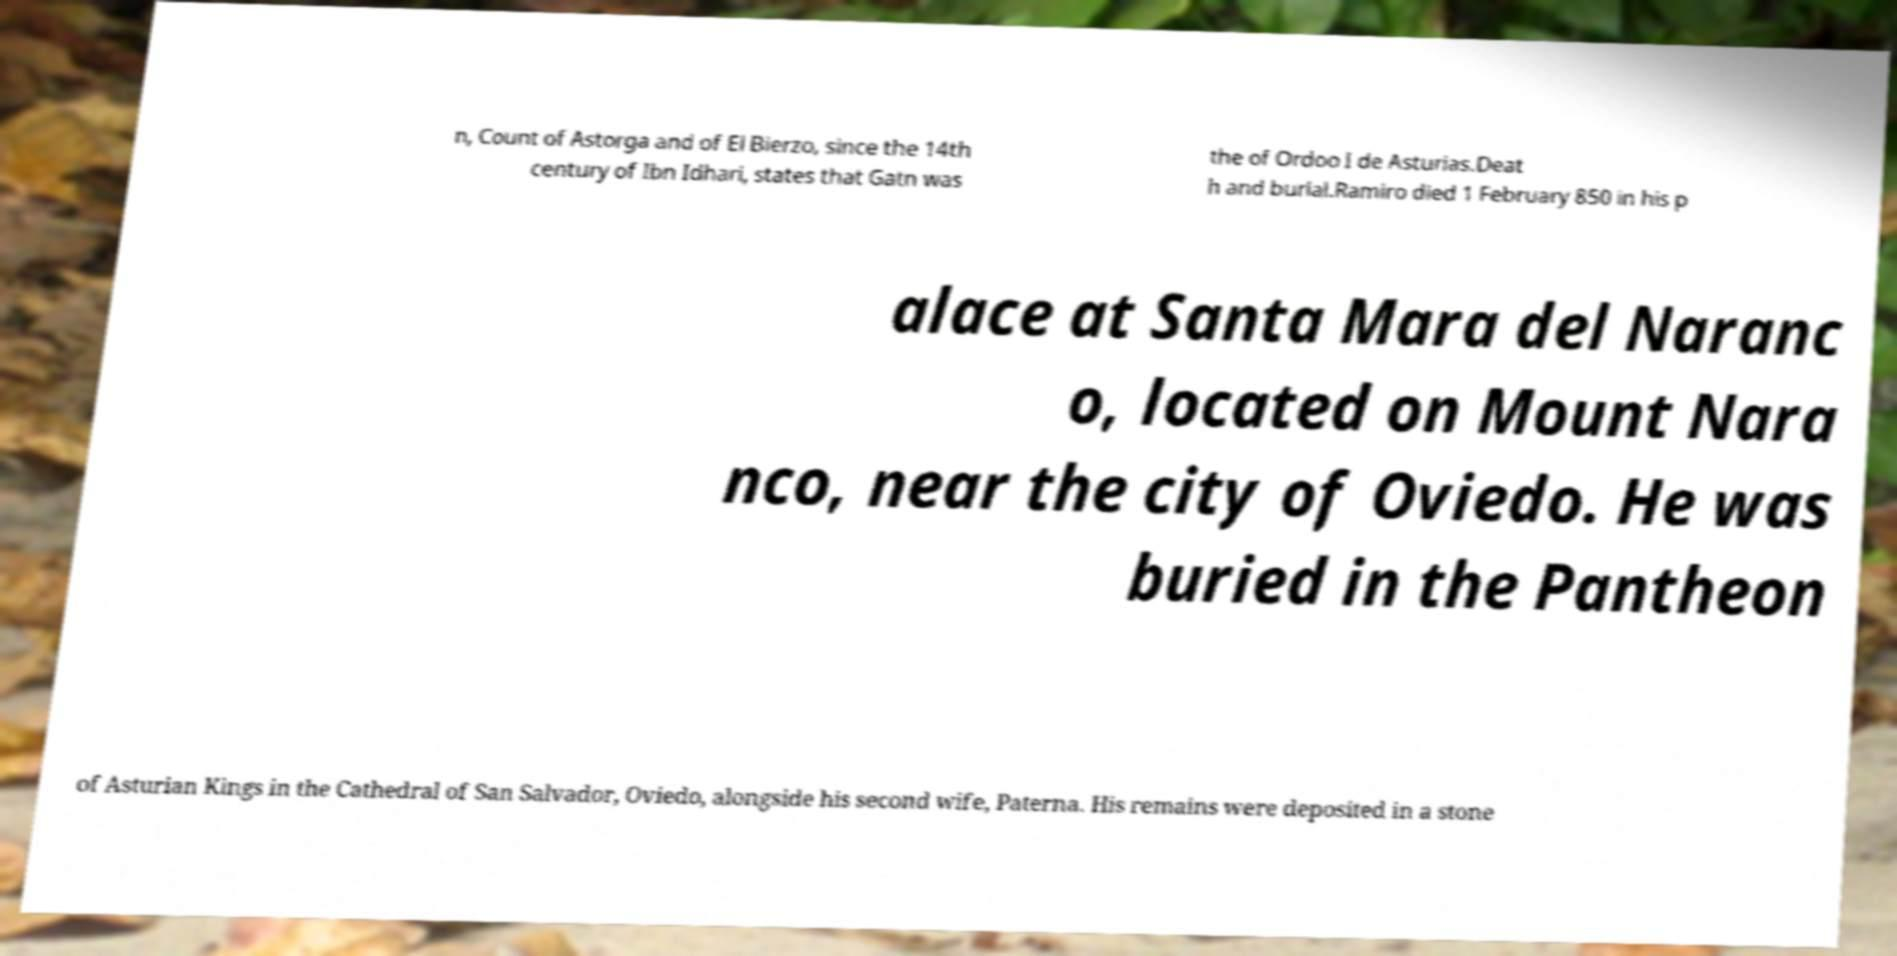Could you extract and type out the text from this image? n, Count of Astorga and of El Bierzo, since the 14th century of Ibn Idhari, states that Gatn was the of Ordoo I de Asturias.Deat h and burial.Ramiro died 1 February 850 in his p alace at Santa Mara del Naranc o, located on Mount Nara nco, near the city of Oviedo. He was buried in the Pantheon of Asturian Kings in the Cathedral of San Salvador, Oviedo, alongside his second wife, Paterna. His remains were deposited in a stone 